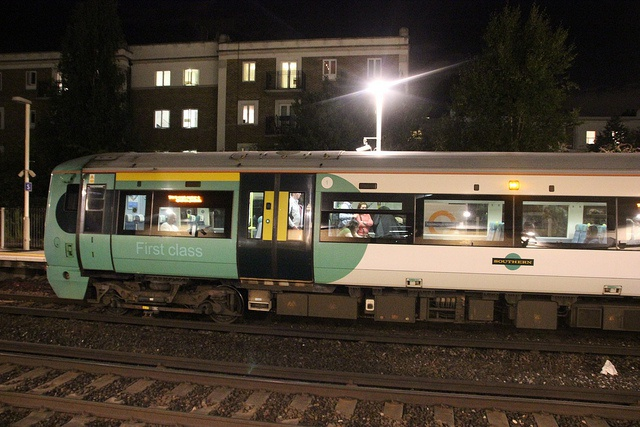Describe the objects in this image and their specific colors. I can see train in black, gray, and tan tones, people in black, lightgray, darkgray, and gray tones, people in black, lightpink, brown, lightgray, and pink tones, people in black, tan, and gray tones, and people in black and gray tones in this image. 